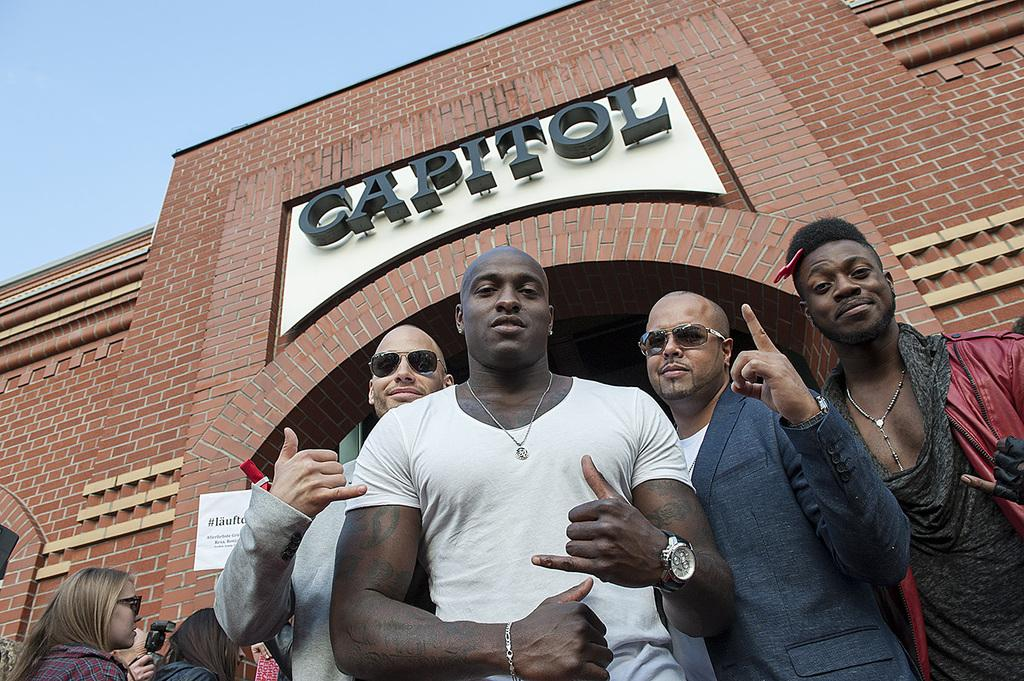What type of structure is visible in the image? There is a building in the image. What objects are present in the image besides the building? There are boards and a camera visible in the image. Are there any people in the image? Yes, there are people in the image. What is the camera being used for in the image? One person is holding the camera, so it is likely being used for taking pictures. Can you see the sea in the image? No, the sea is not present in the image. Is there any mention of an eye in the image? No, there is no mention of an eye in the image. 